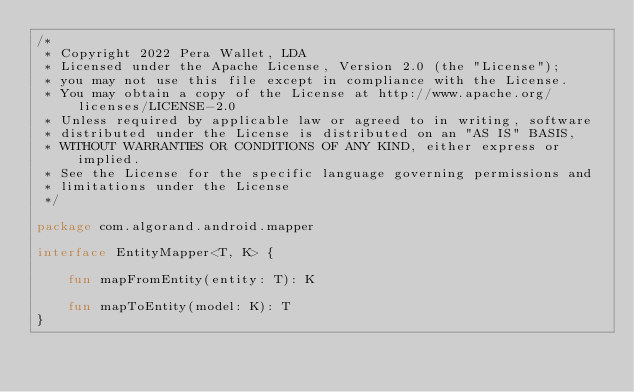<code> <loc_0><loc_0><loc_500><loc_500><_Kotlin_>/*
 * Copyright 2022 Pera Wallet, LDA
 * Licensed under the Apache License, Version 2.0 (the "License");
 * you may not use this file except in compliance with the License.
 * You may obtain a copy of the License at http://www.apache.org/licenses/LICENSE-2.0
 * Unless required by applicable law or agreed to in writing, software
 * distributed under the License is distributed on an "AS IS" BASIS,
 * WITHOUT WARRANTIES OR CONDITIONS OF ANY KIND, either express or implied.
 * See the License for the specific language governing permissions and
 * limitations under the License
 */

package com.algorand.android.mapper

interface EntityMapper<T, K> {

    fun mapFromEntity(entity: T): K

    fun mapToEntity(model: K): T
}
</code> 